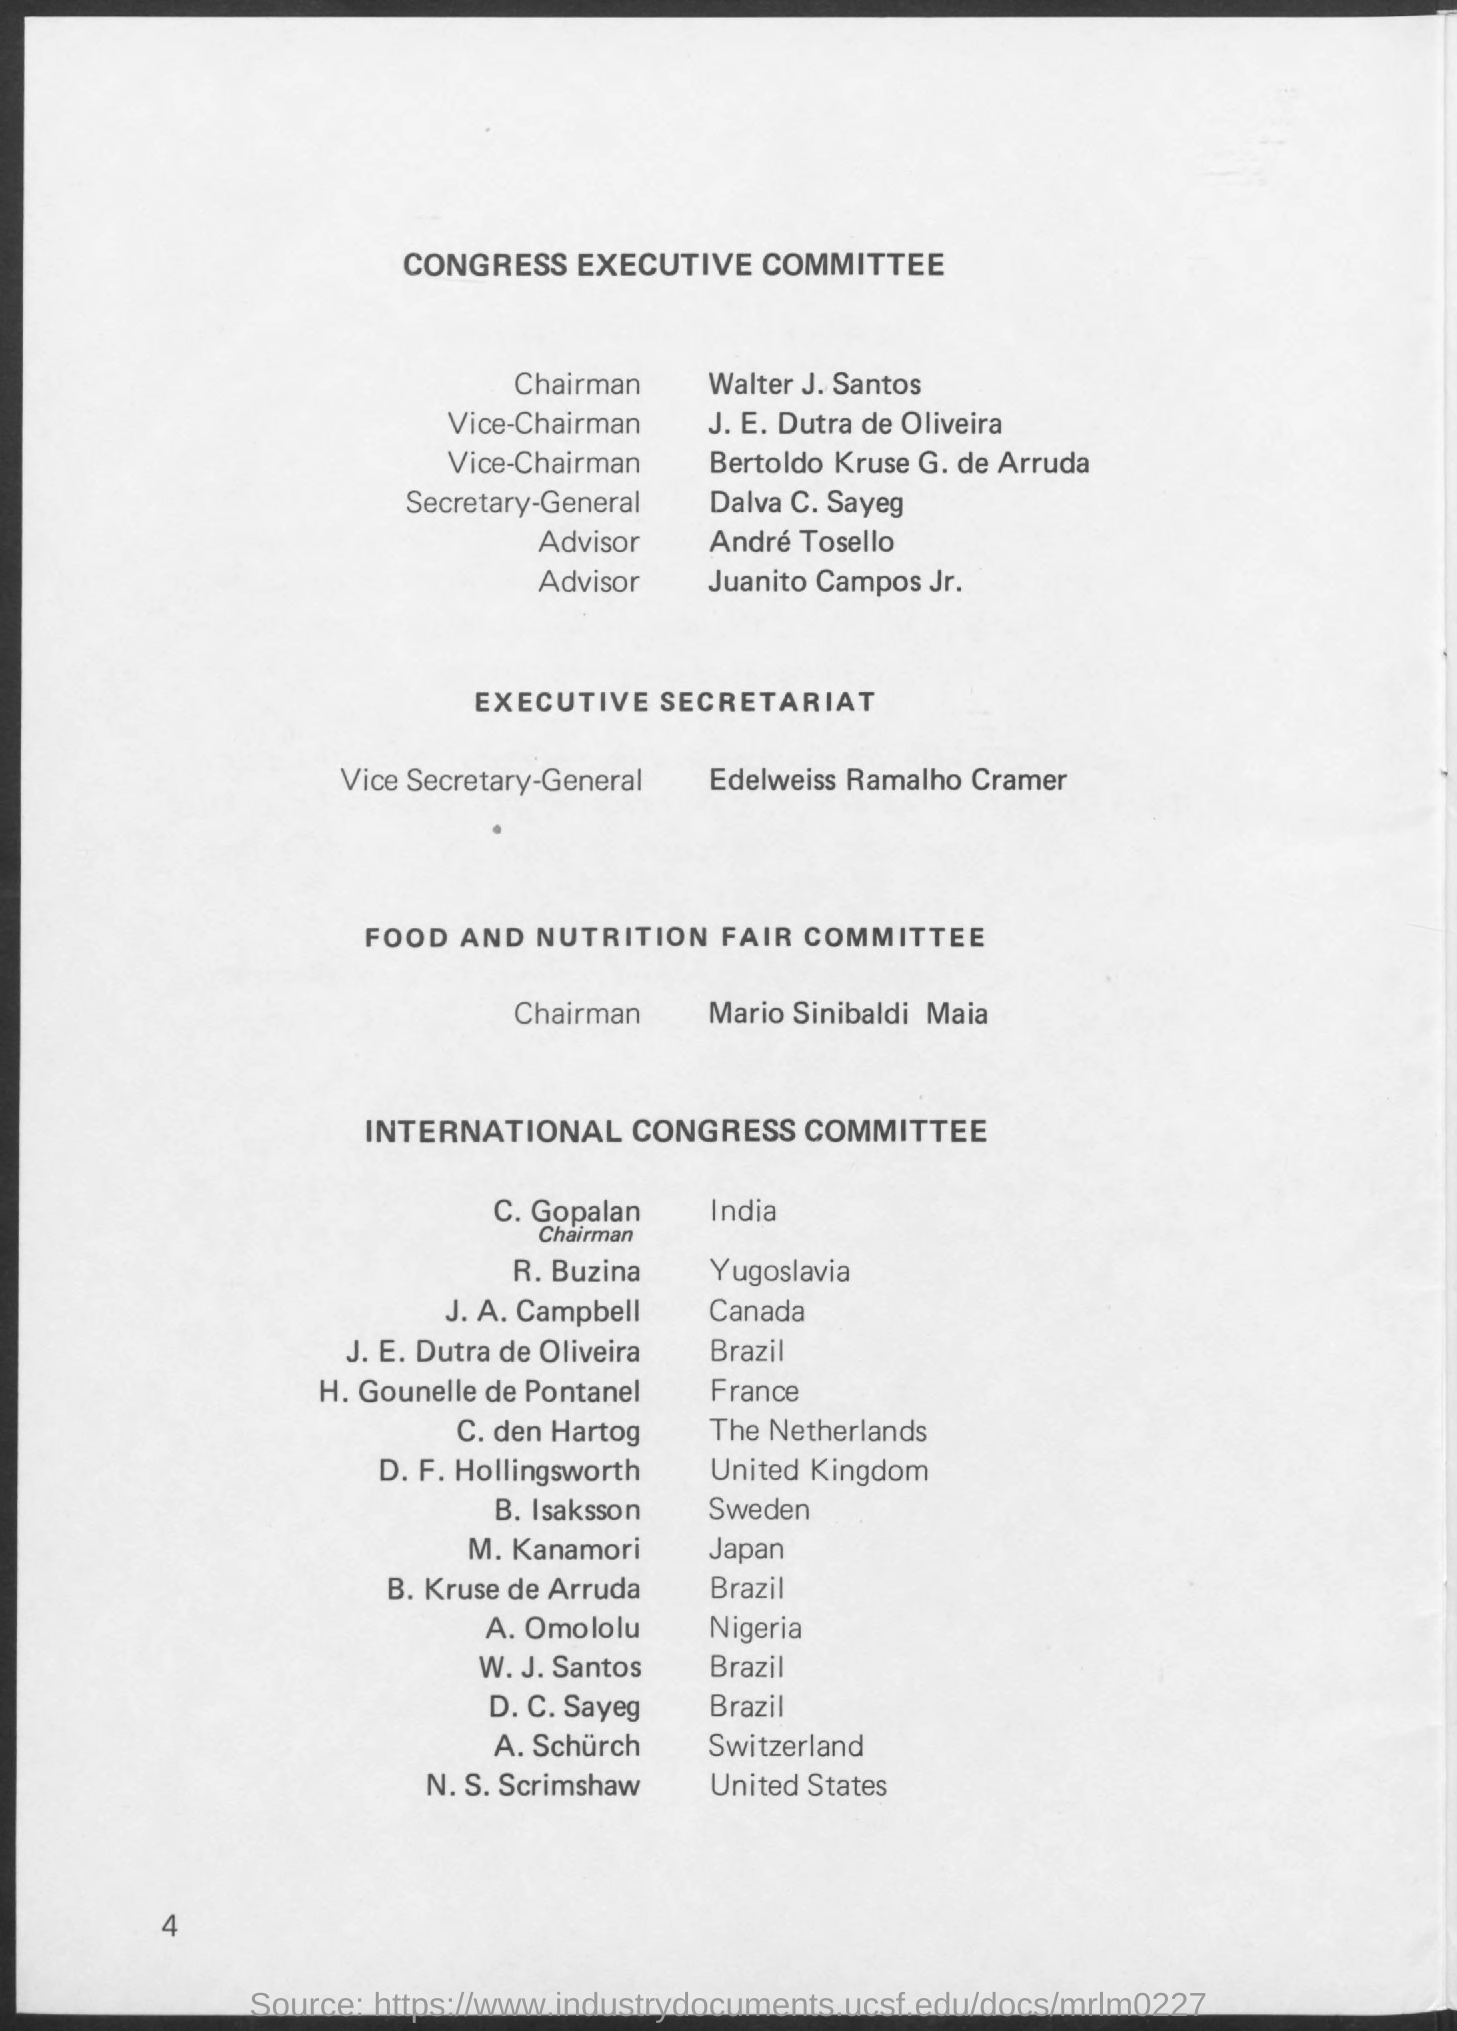Who is the Chairman for Congress executive committee?
Make the answer very short. Walter J. Santos. Who is the Secretary-General  for Congress executive committee?
Your response must be concise. Dalva C. Sayeg. Who is the Vice Secretary-General for Executive Secretariat?
Provide a succinct answer. Edelweiss Ramalho Cramer. Who is the Chairman for Food and Nutrition Fair committee?
Make the answer very short. Mario Sinibaldi Maia. Who is in International Congress Committee for India?
Your answer should be very brief. C. Gopalan. Who is in International Congress Committee for Yugoslavia?
Keep it short and to the point. R. Buzina. Who is in International Congress Committee for Canada?
Offer a terse response. J. A. Campbell. Who is in International Congress Committee for Brazil?
Make the answer very short. J. E. Dutra de Oliveira. Who is in International Congress Committee for Japan?
Provide a succinct answer. M. Kanamori. Who is in International Congress Committee for Nigeria?
Give a very brief answer. A. Omololu. 